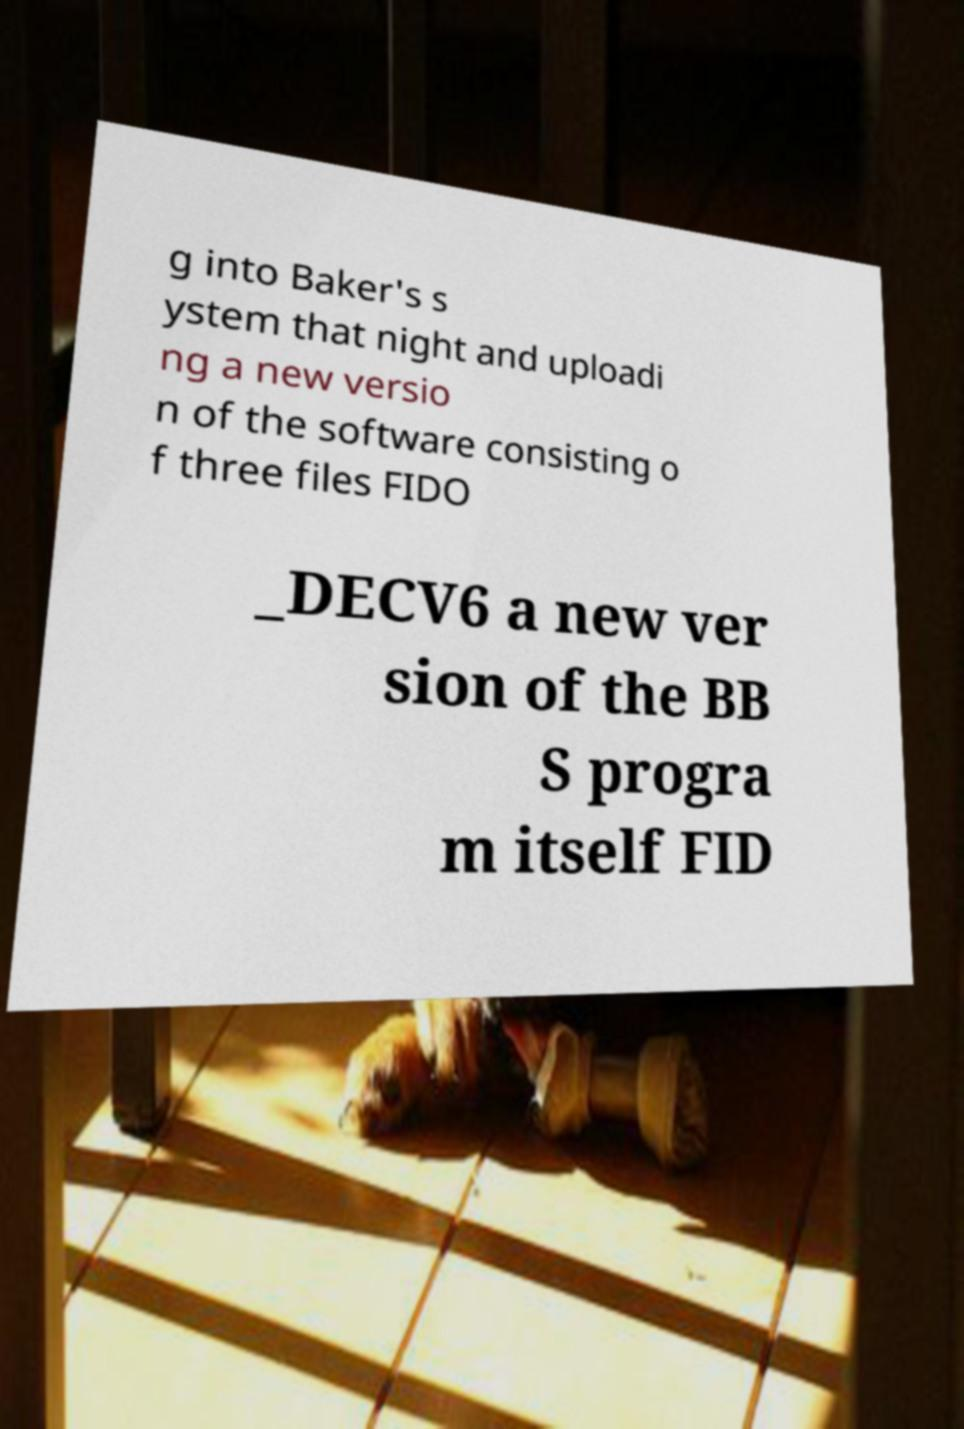There's text embedded in this image that I need extracted. Can you transcribe it verbatim? g into Baker's s ystem that night and uploadi ng a new versio n of the software consisting o f three files FIDO _DECV6 a new ver sion of the BB S progra m itself FID 